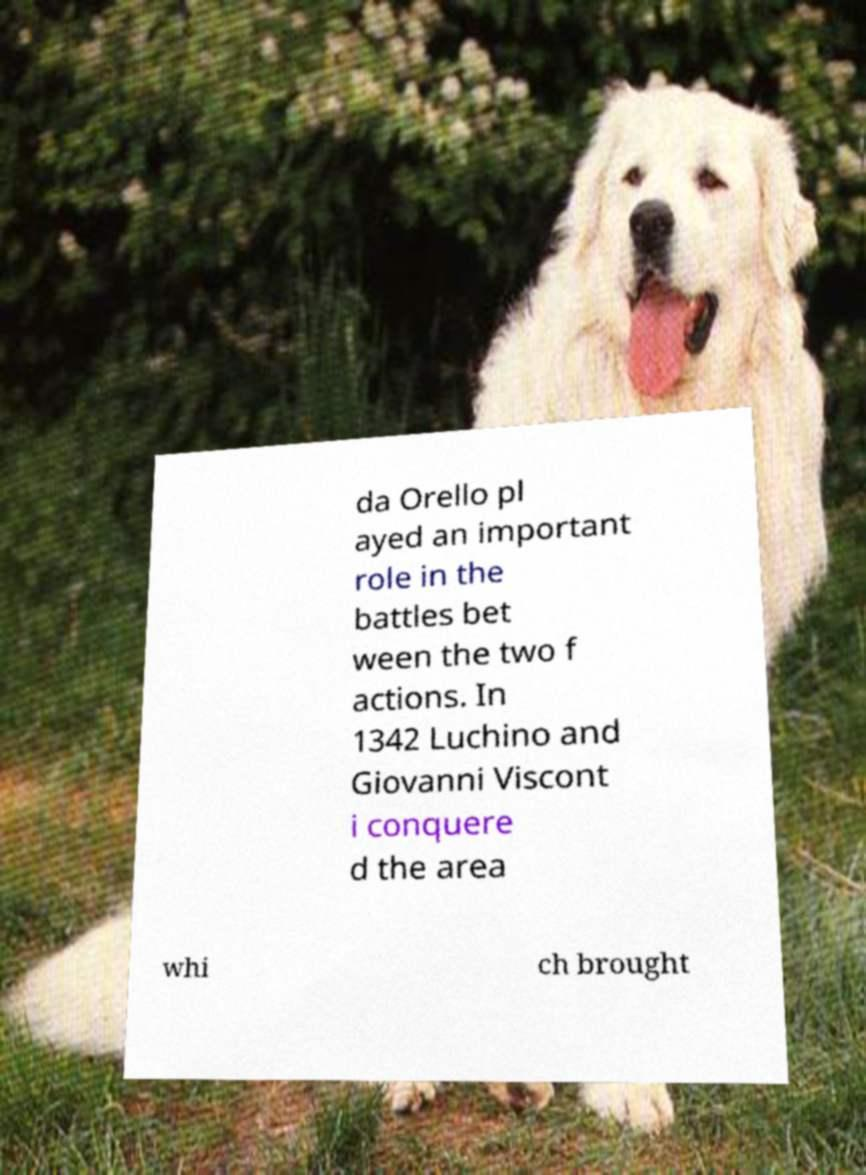Can you accurately transcribe the text from the provided image for me? da Orello pl ayed an important role in the battles bet ween the two f actions. In 1342 Luchino and Giovanni Viscont i conquere d the area whi ch brought 